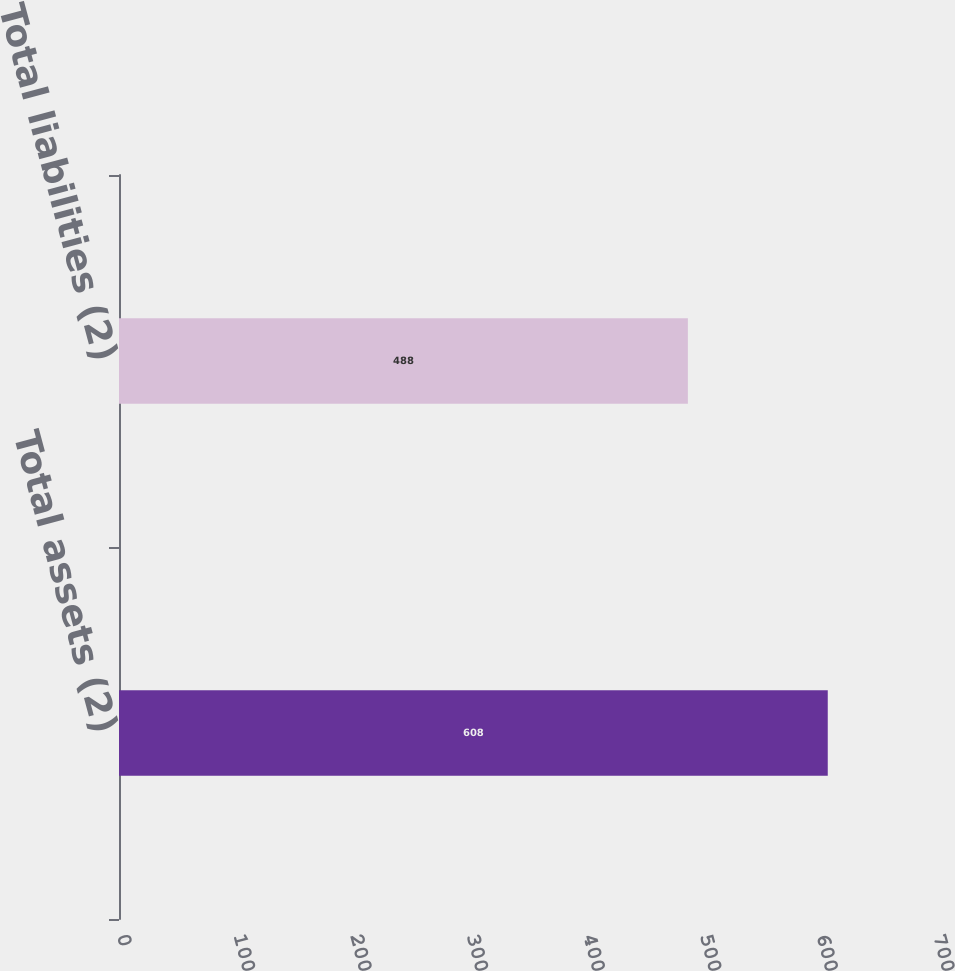<chart> <loc_0><loc_0><loc_500><loc_500><bar_chart><fcel>Total assets (2)<fcel>Total liabilities (2)<nl><fcel>608<fcel>488<nl></chart> 